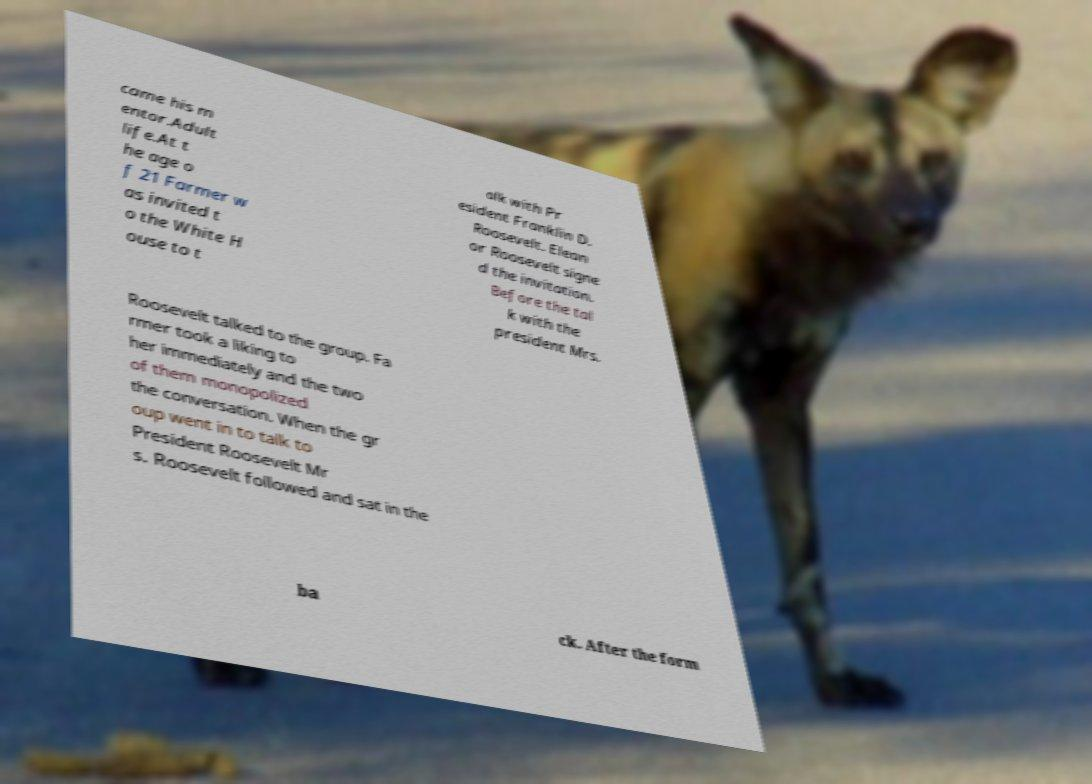Can you accurately transcribe the text from the provided image for me? came his m entor.Adult life.At t he age o f 21 Farmer w as invited t o the White H ouse to t alk with Pr esident Franklin D. Roosevelt. Elean or Roosevelt signe d the invitation. Before the tal k with the president Mrs. Roosevelt talked to the group. Fa rmer took a liking to her immediately and the two of them monopolized the conversation. When the gr oup went in to talk to President Roosevelt Mr s. Roosevelt followed and sat in the ba ck. After the form 